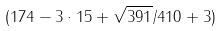<formula> <loc_0><loc_0><loc_500><loc_500>( 1 7 4 - 3 \cdot 1 5 + \sqrt { 3 9 1 } / 4 1 0 + 3 )</formula> 